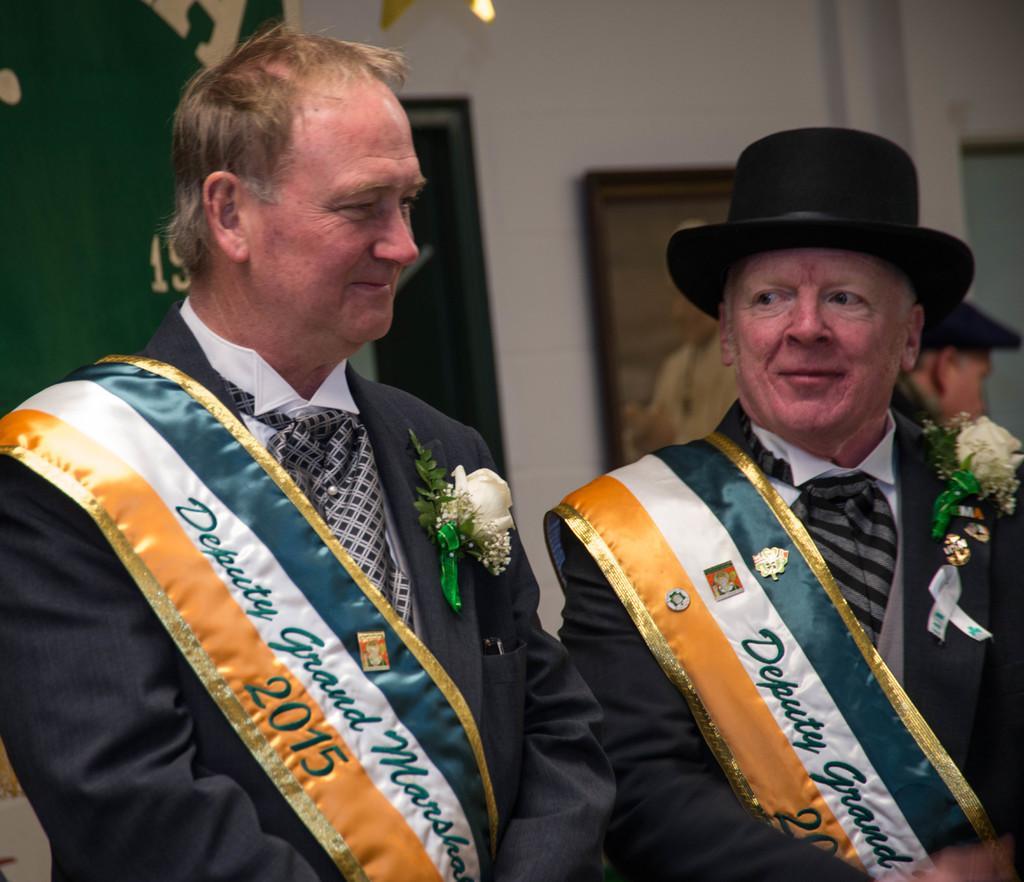In one or two sentences, can you explain what this image depicts? In this image there are two persons standing and smiling, and in the background there is another person, frames attached to the wall. 